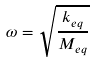Convert formula to latex. <formula><loc_0><loc_0><loc_500><loc_500>\omega = \sqrt { \frac { k _ { e q } } { M _ { e q } } }</formula> 